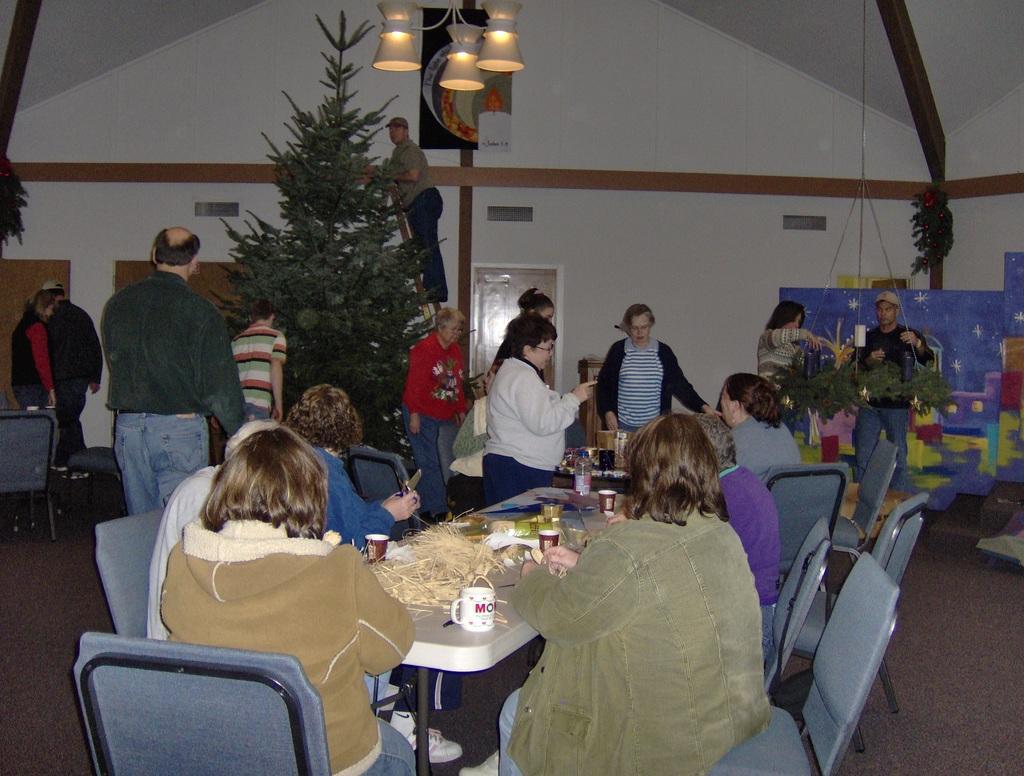Could you give a brief overview of what you see in this image? The picture is taken in a closed room where in the middle of the picture people are sitting on the chairs and in front of them there is a table on which cups, plates, water bottle and grass is present and at the right corner of the picture there is one christmas tree placed and one person is on the ladder behind the tree and there are two people standing at the corner and at the right corner of the picture two people are arranging some trees hanged from the wall and behind them there is a big wall and a door. 